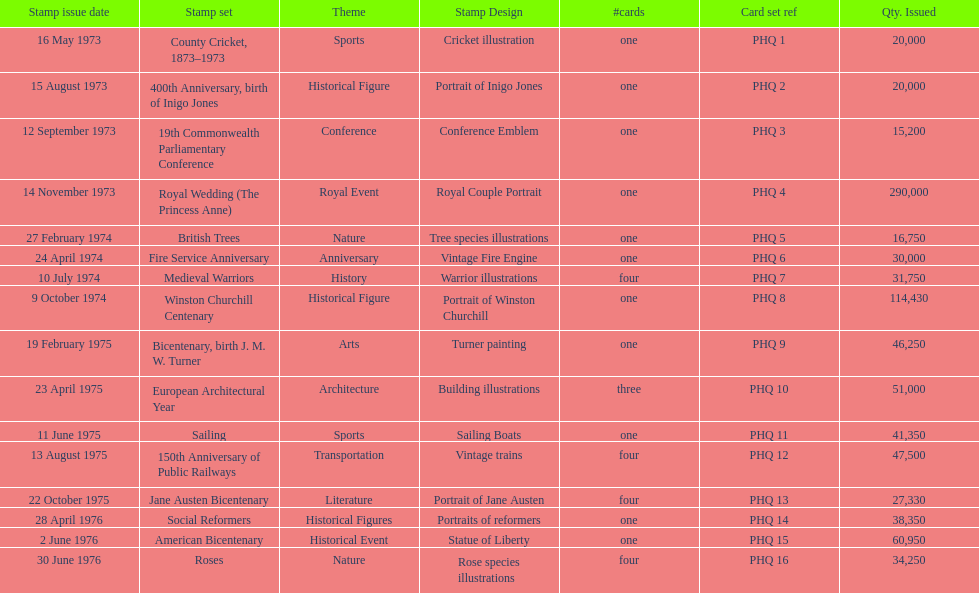Which year had the most stamps issued? 1973. 